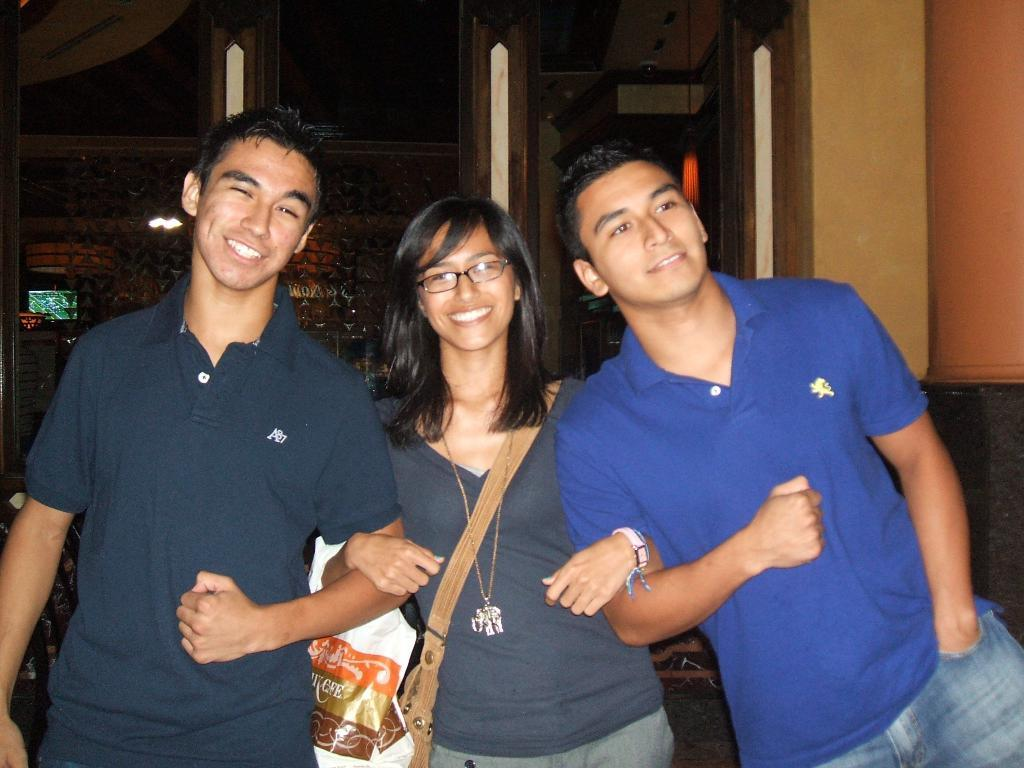Where was the image taken? The image is taken indoors. How many people are in the image? Two men and a woman are standing in the middle of the image. What are the individuals doing in the image? The individuals are smiling. What can be seen in the background of the image? There is a wall in the background of the image. What type of system is visible in the background of the image? There is no system visible in the background of the image; it only shows a wall. What direction are the individuals facing in the image? The provided facts do not specify the direction the individuals are facing, so we cannot definitively answer that question. 